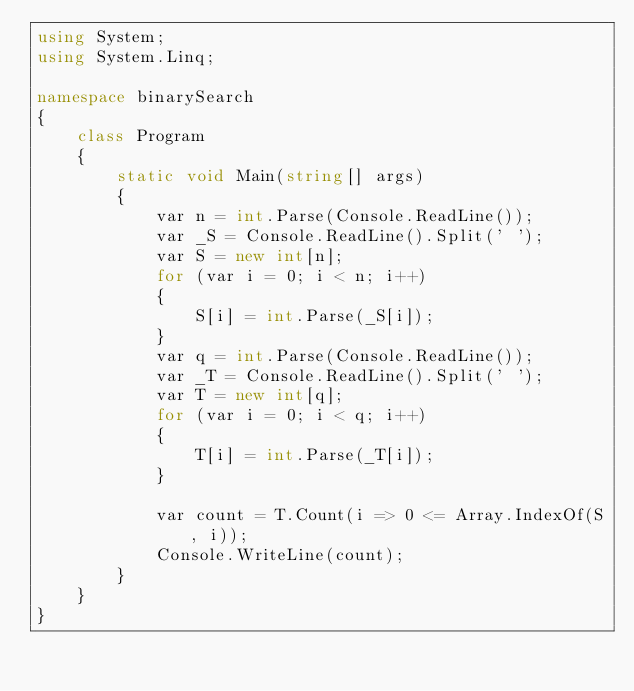Convert code to text. <code><loc_0><loc_0><loc_500><loc_500><_C#_>using System;
using System.Linq;

namespace binarySearch
{
    class Program
    {
        static void Main(string[] args)
        {
            var n = int.Parse(Console.ReadLine());
            var _S = Console.ReadLine().Split(' ');
            var S = new int[n];
            for (var i = 0; i < n; i++)
            {
                S[i] = int.Parse(_S[i]);
            }
            var q = int.Parse(Console.ReadLine());
            var _T = Console.ReadLine().Split(' ');
            var T = new int[q];
            for (var i = 0; i < q; i++)
            {
                T[i] = int.Parse(_T[i]);
            }

            var count = T.Count(i => 0 <= Array.IndexOf(S, i));
            Console.WriteLine(count);
        }
    }
}</code> 